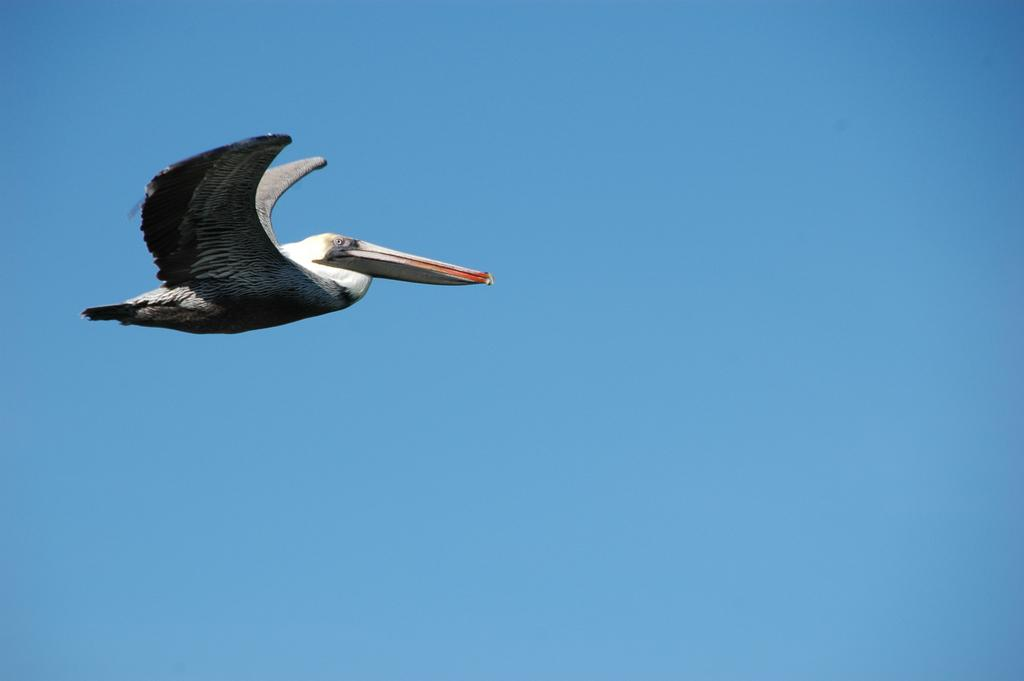What type of animal can be seen in the image? There is a bird in the image. What is the bird doing in the image? The bird is flying in the air. What can be seen in the background of the image? There is sky visible in the background of the image. What type of berry is the bird holding in its beak in the image? There is no berry present in the image; the bird is simply flying in the air. 